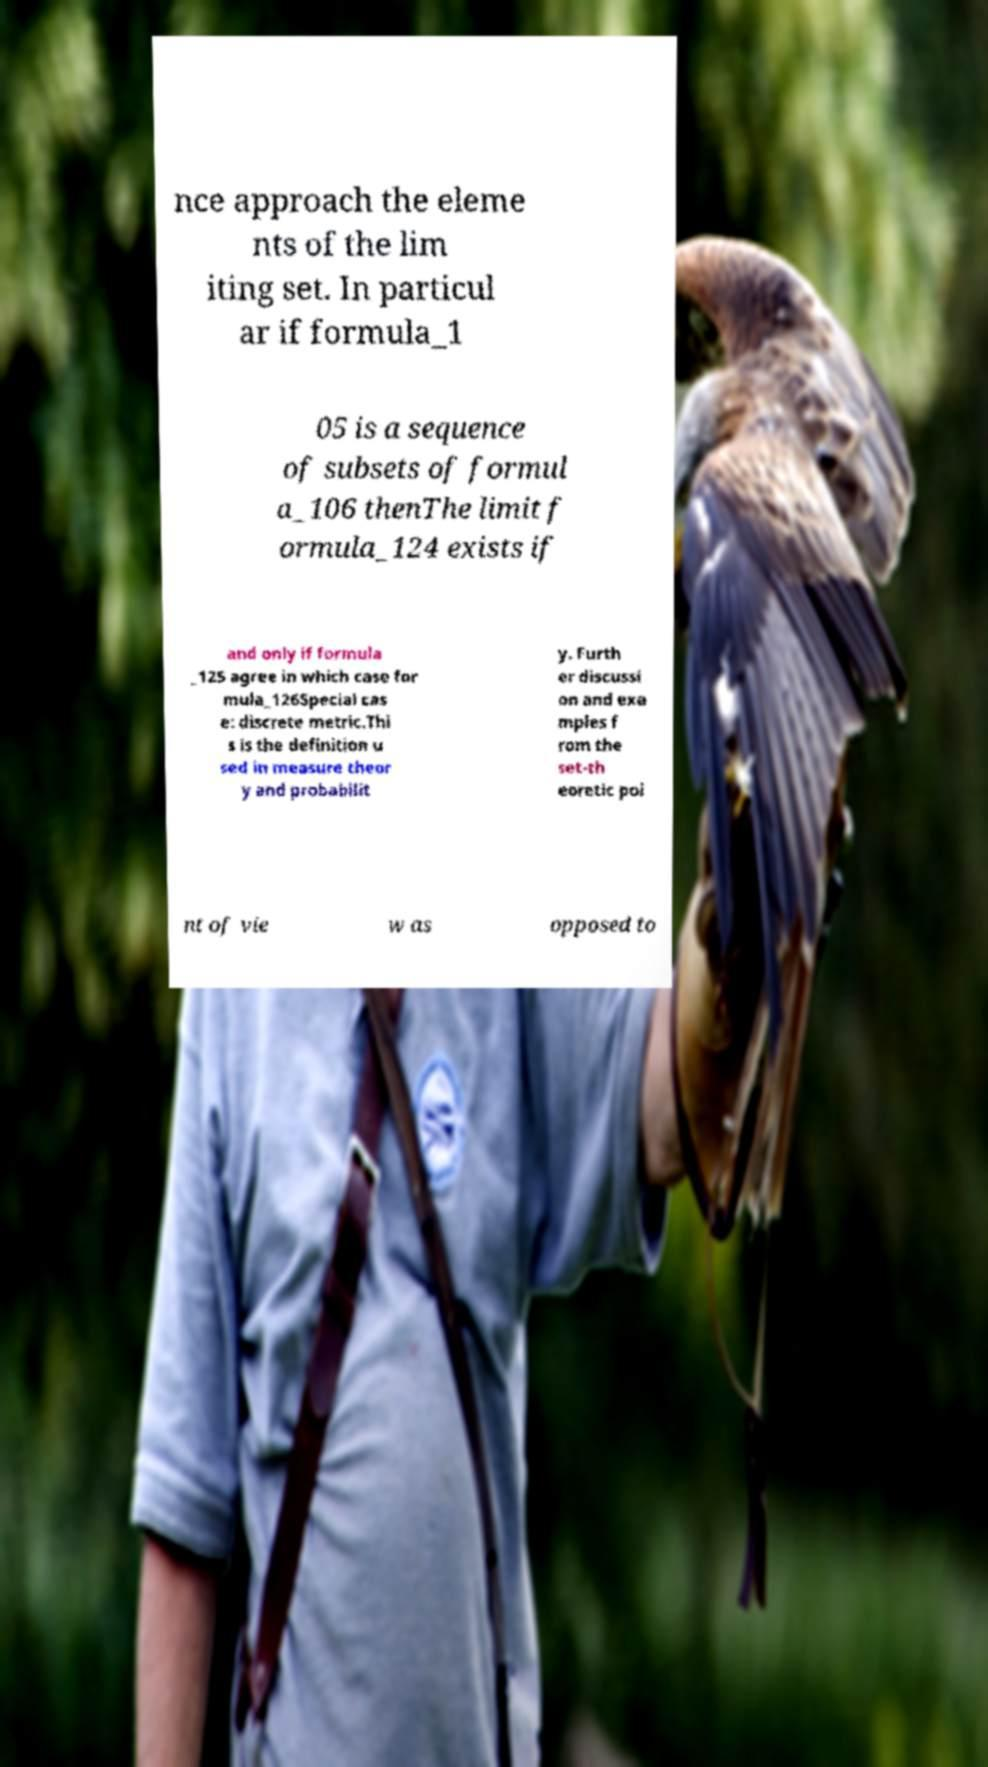Could you assist in decoding the text presented in this image and type it out clearly? nce approach the eleme nts of the lim iting set. In particul ar if formula_1 05 is a sequence of subsets of formul a_106 thenThe limit f ormula_124 exists if and only if formula _125 agree in which case for mula_126Special cas e: discrete metric.Thi s is the definition u sed in measure theor y and probabilit y. Furth er discussi on and exa mples f rom the set-th eoretic poi nt of vie w as opposed to 